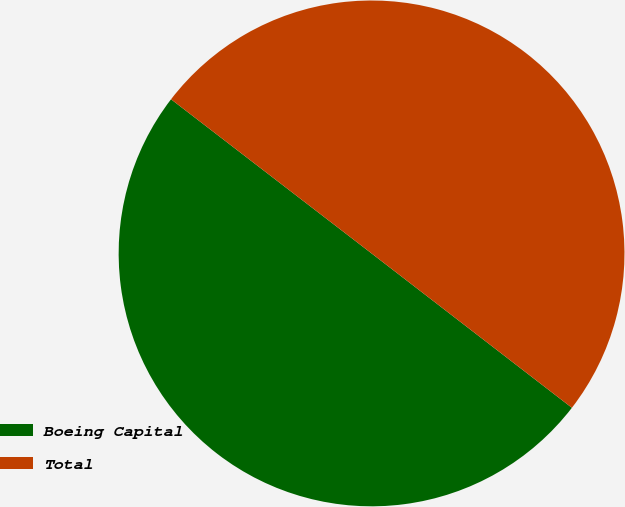Convert chart to OTSL. <chart><loc_0><loc_0><loc_500><loc_500><pie_chart><fcel>Boeing Capital<fcel>Total<nl><fcel>49.98%<fcel>50.02%<nl></chart> 